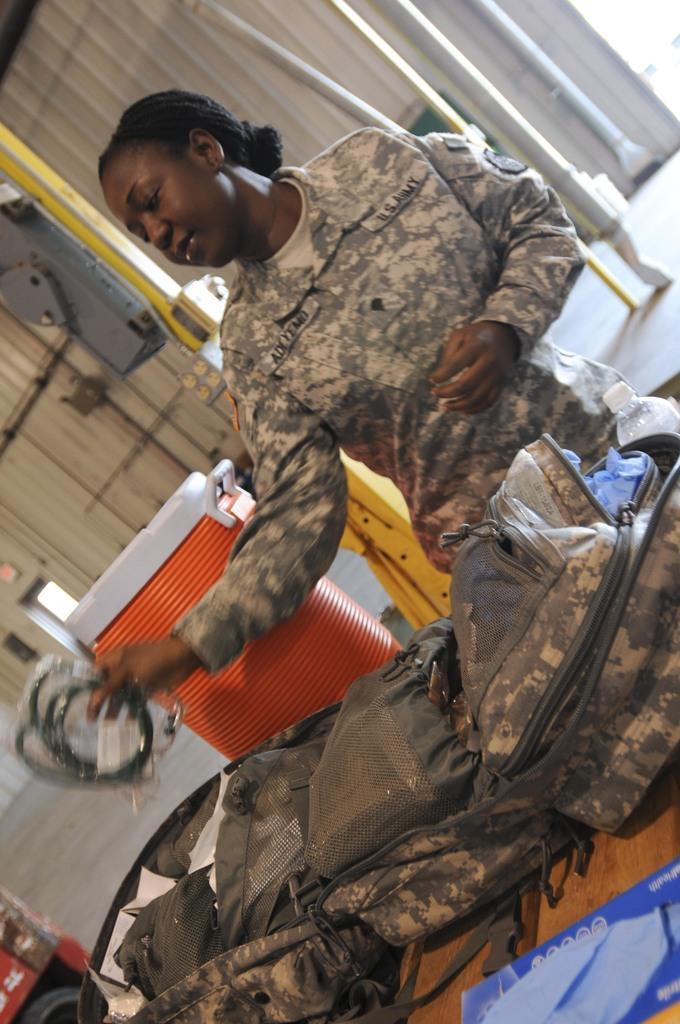Can you describe this image briefly? In this image we can see a lady soldier who is checking the bag which is on table and at the background of the image there is trash box, poles and iron sheet. 